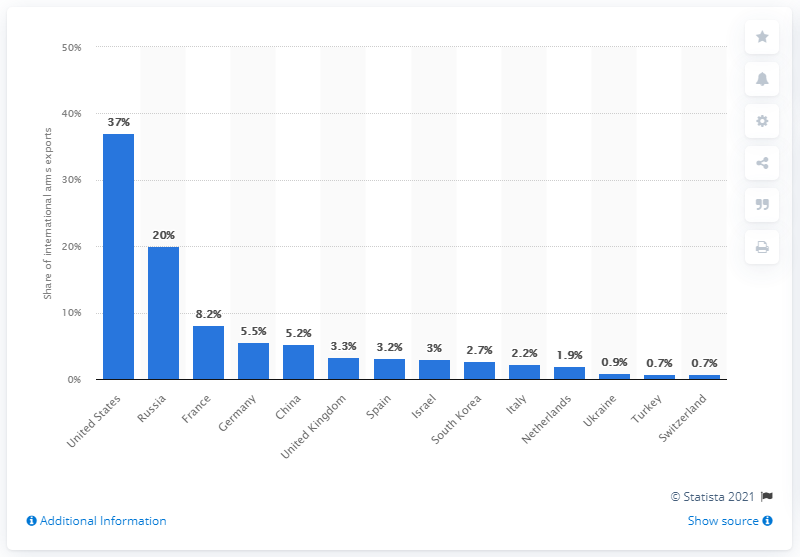Outline some significant characteristics in this image. Russia was the second largest supplier of major weapons between 2016 and 2020. 